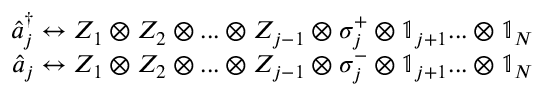<formula> <loc_0><loc_0><loc_500><loc_500>\begin{array} { r } { \hat { a } _ { j } ^ { \dagger } \leftrightarrow Z _ { 1 } \otimes Z _ { 2 } \otimes \dots \otimes Z _ { j - 1 } \otimes \sigma _ { j } ^ { + } \otimes \mathbb { 1 } _ { j + 1 } \dots \otimes \mathbb { 1 } _ { N } } \\ { \hat { a } _ { j } \leftrightarrow Z _ { 1 } \otimes Z _ { 2 } \otimes \dots \otimes Z _ { j - 1 } \otimes \sigma _ { j } ^ { - } \otimes \mathbb { 1 } _ { j + 1 } \dots \otimes \mathbb { 1 } _ { N } } \end{array}</formula> 